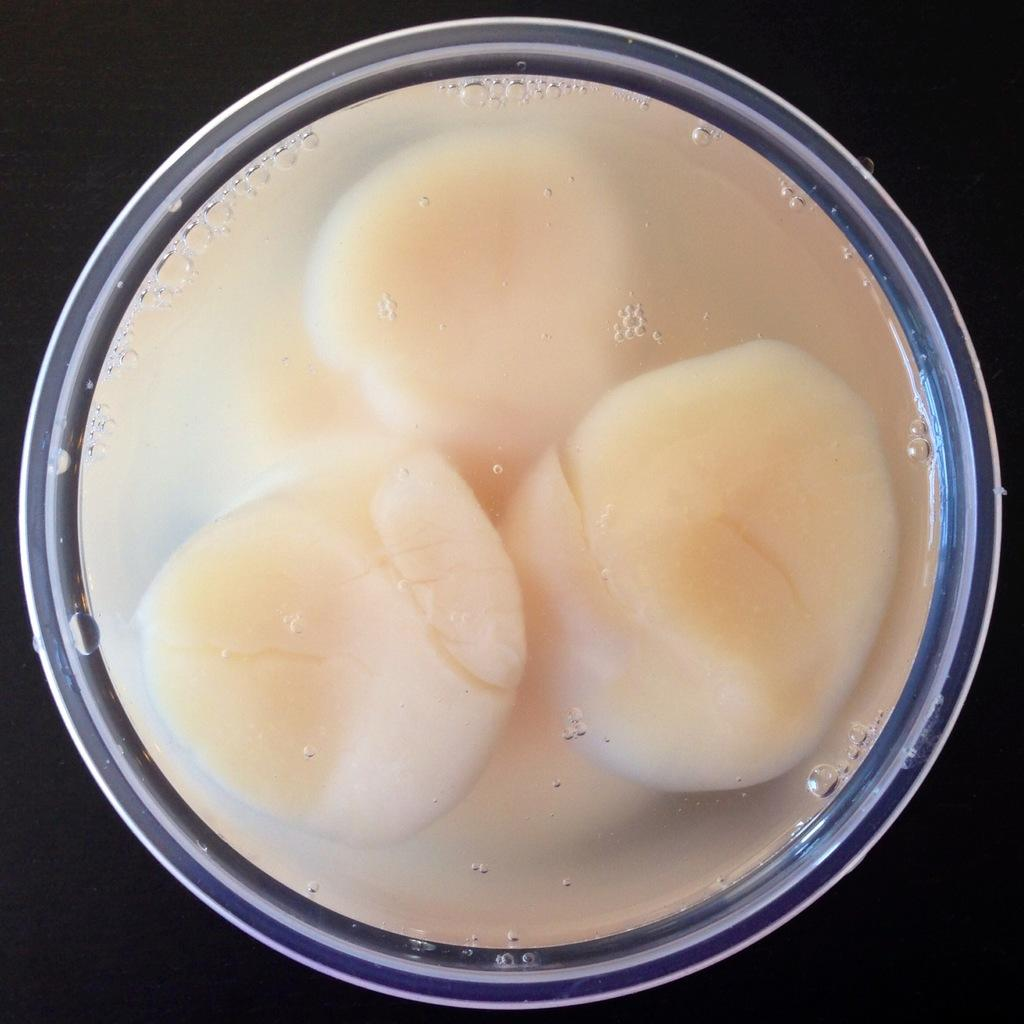What is in the bowl that is visible in the image? There is water in the bowl. Besides water, what else can be seen in the bowl? There are white color objects in the bowl. Where is the lunchroom located in the image? There is no lunchroom present in the image. Can you see any frogs or mice in the image? There are no frogs or mice present in the image. 